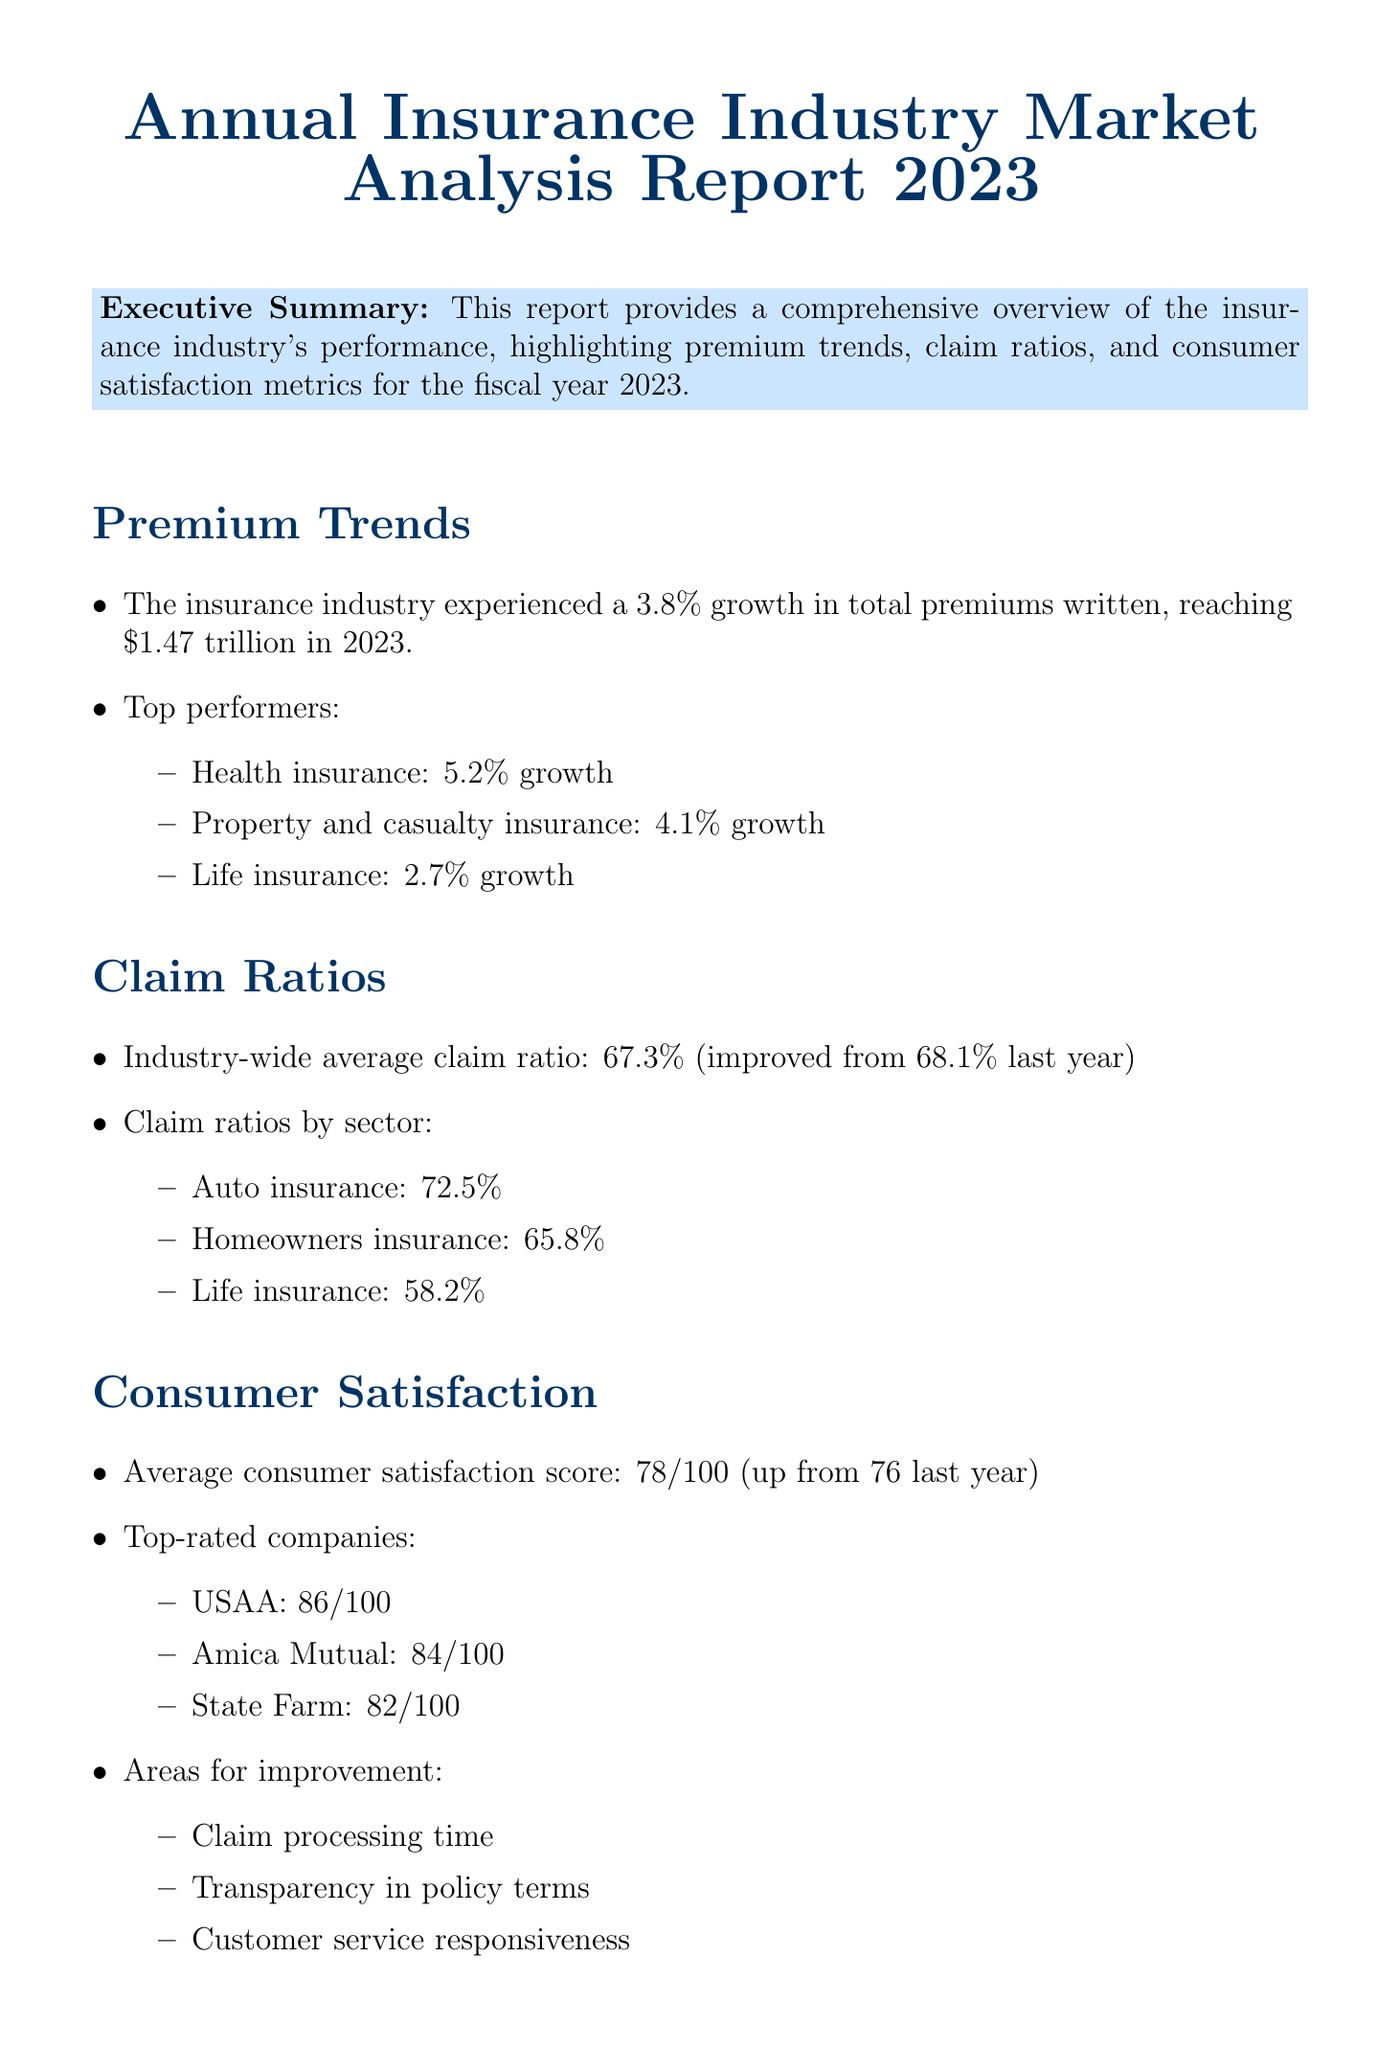What was the overall growth rate of the insurance industry in 2023? The overall growth rate is stated in the premium trends section of the report.
Answer: 3.8% What was the total amount of premiums written in 2023? The total premiums written is provided in the premium trends section.
Answer: $1.47 trillion Which insurance sector had the highest growth rate? This information can be found in the premium trends section under top performers.
Answer: Health insurance What is the average claim ratio for the insurance industry? The average claim ratio is mentioned in the claim ratios section.
Answer: 67.3% Who are the top-rated insurance companies based on consumer satisfaction? The names of the top-rated companies are listed in the consumer satisfaction section.
Answer: USAA, Amica Mutual, State Farm What score represents the average consumer satisfaction in 2023? The average score is provided in the consumer satisfaction section of the report.
Answer: 78 out of 100 What key area is suggested for regulatory action regarding policy disclosures? Recommended areas for regulation are listed in the regulatory implications section.
Answer: Enhancing transparency in policy disclosures Which aspect of consumer service was noted for improvement? Areas for improvement are discussed in the consumer satisfaction section.
Answer: Claim processing time What proposed action is mentioned to address regulatory concerns? The proposed action is specified in the regulatory implications section.
Answer: Develop new regulations to address identified areas of concern and promote fair practices across the insurance industry 